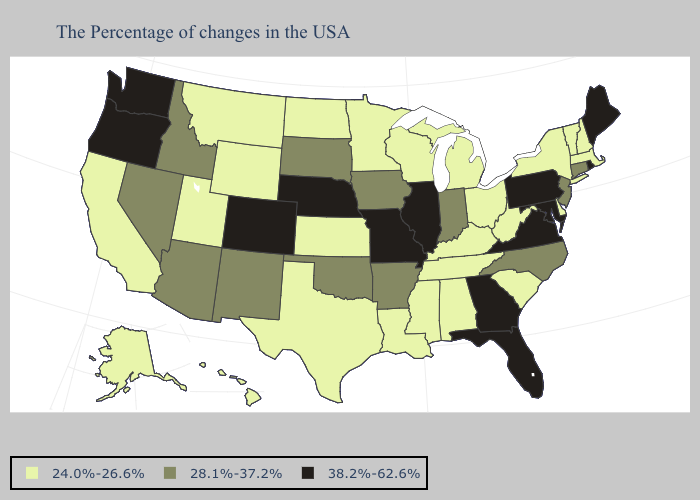Name the states that have a value in the range 24.0%-26.6%?
Be succinct. Massachusetts, New Hampshire, Vermont, New York, Delaware, South Carolina, West Virginia, Ohio, Michigan, Kentucky, Alabama, Tennessee, Wisconsin, Mississippi, Louisiana, Minnesota, Kansas, Texas, North Dakota, Wyoming, Utah, Montana, California, Alaska, Hawaii. Among the states that border Iowa , which have the lowest value?
Give a very brief answer. Wisconsin, Minnesota. Name the states that have a value in the range 38.2%-62.6%?
Be succinct. Maine, Rhode Island, Maryland, Pennsylvania, Virginia, Florida, Georgia, Illinois, Missouri, Nebraska, Colorado, Washington, Oregon. Does Connecticut have a higher value than Kentucky?
Answer briefly. Yes. Name the states that have a value in the range 38.2%-62.6%?
Quick response, please. Maine, Rhode Island, Maryland, Pennsylvania, Virginia, Florida, Georgia, Illinois, Missouri, Nebraska, Colorado, Washington, Oregon. Does Georgia have the highest value in the South?
Be succinct. Yes. Does North Dakota have the same value as Minnesota?
Short answer required. Yes. What is the value of Minnesota?
Quick response, please. 24.0%-26.6%. Is the legend a continuous bar?
Short answer required. No. Does Wisconsin have the lowest value in the USA?
Concise answer only. Yes. Among the states that border Michigan , which have the lowest value?
Keep it brief. Ohio, Wisconsin. Name the states that have a value in the range 24.0%-26.6%?
Short answer required. Massachusetts, New Hampshire, Vermont, New York, Delaware, South Carolina, West Virginia, Ohio, Michigan, Kentucky, Alabama, Tennessee, Wisconsin, Mississippi, Louisiana, Minnesota, Kansas, Texas, North Dakota, Wyoming, Utah, Montana, California, Alaska, Hawaii. What is the value of Kentucky?
Give a very brief answer. 24.0%-26.6%. Does the map have missing data?
Be succinct. No. What is the highest value in states that border Indiana?
Keep it brief. 38.2%-62.6%. 